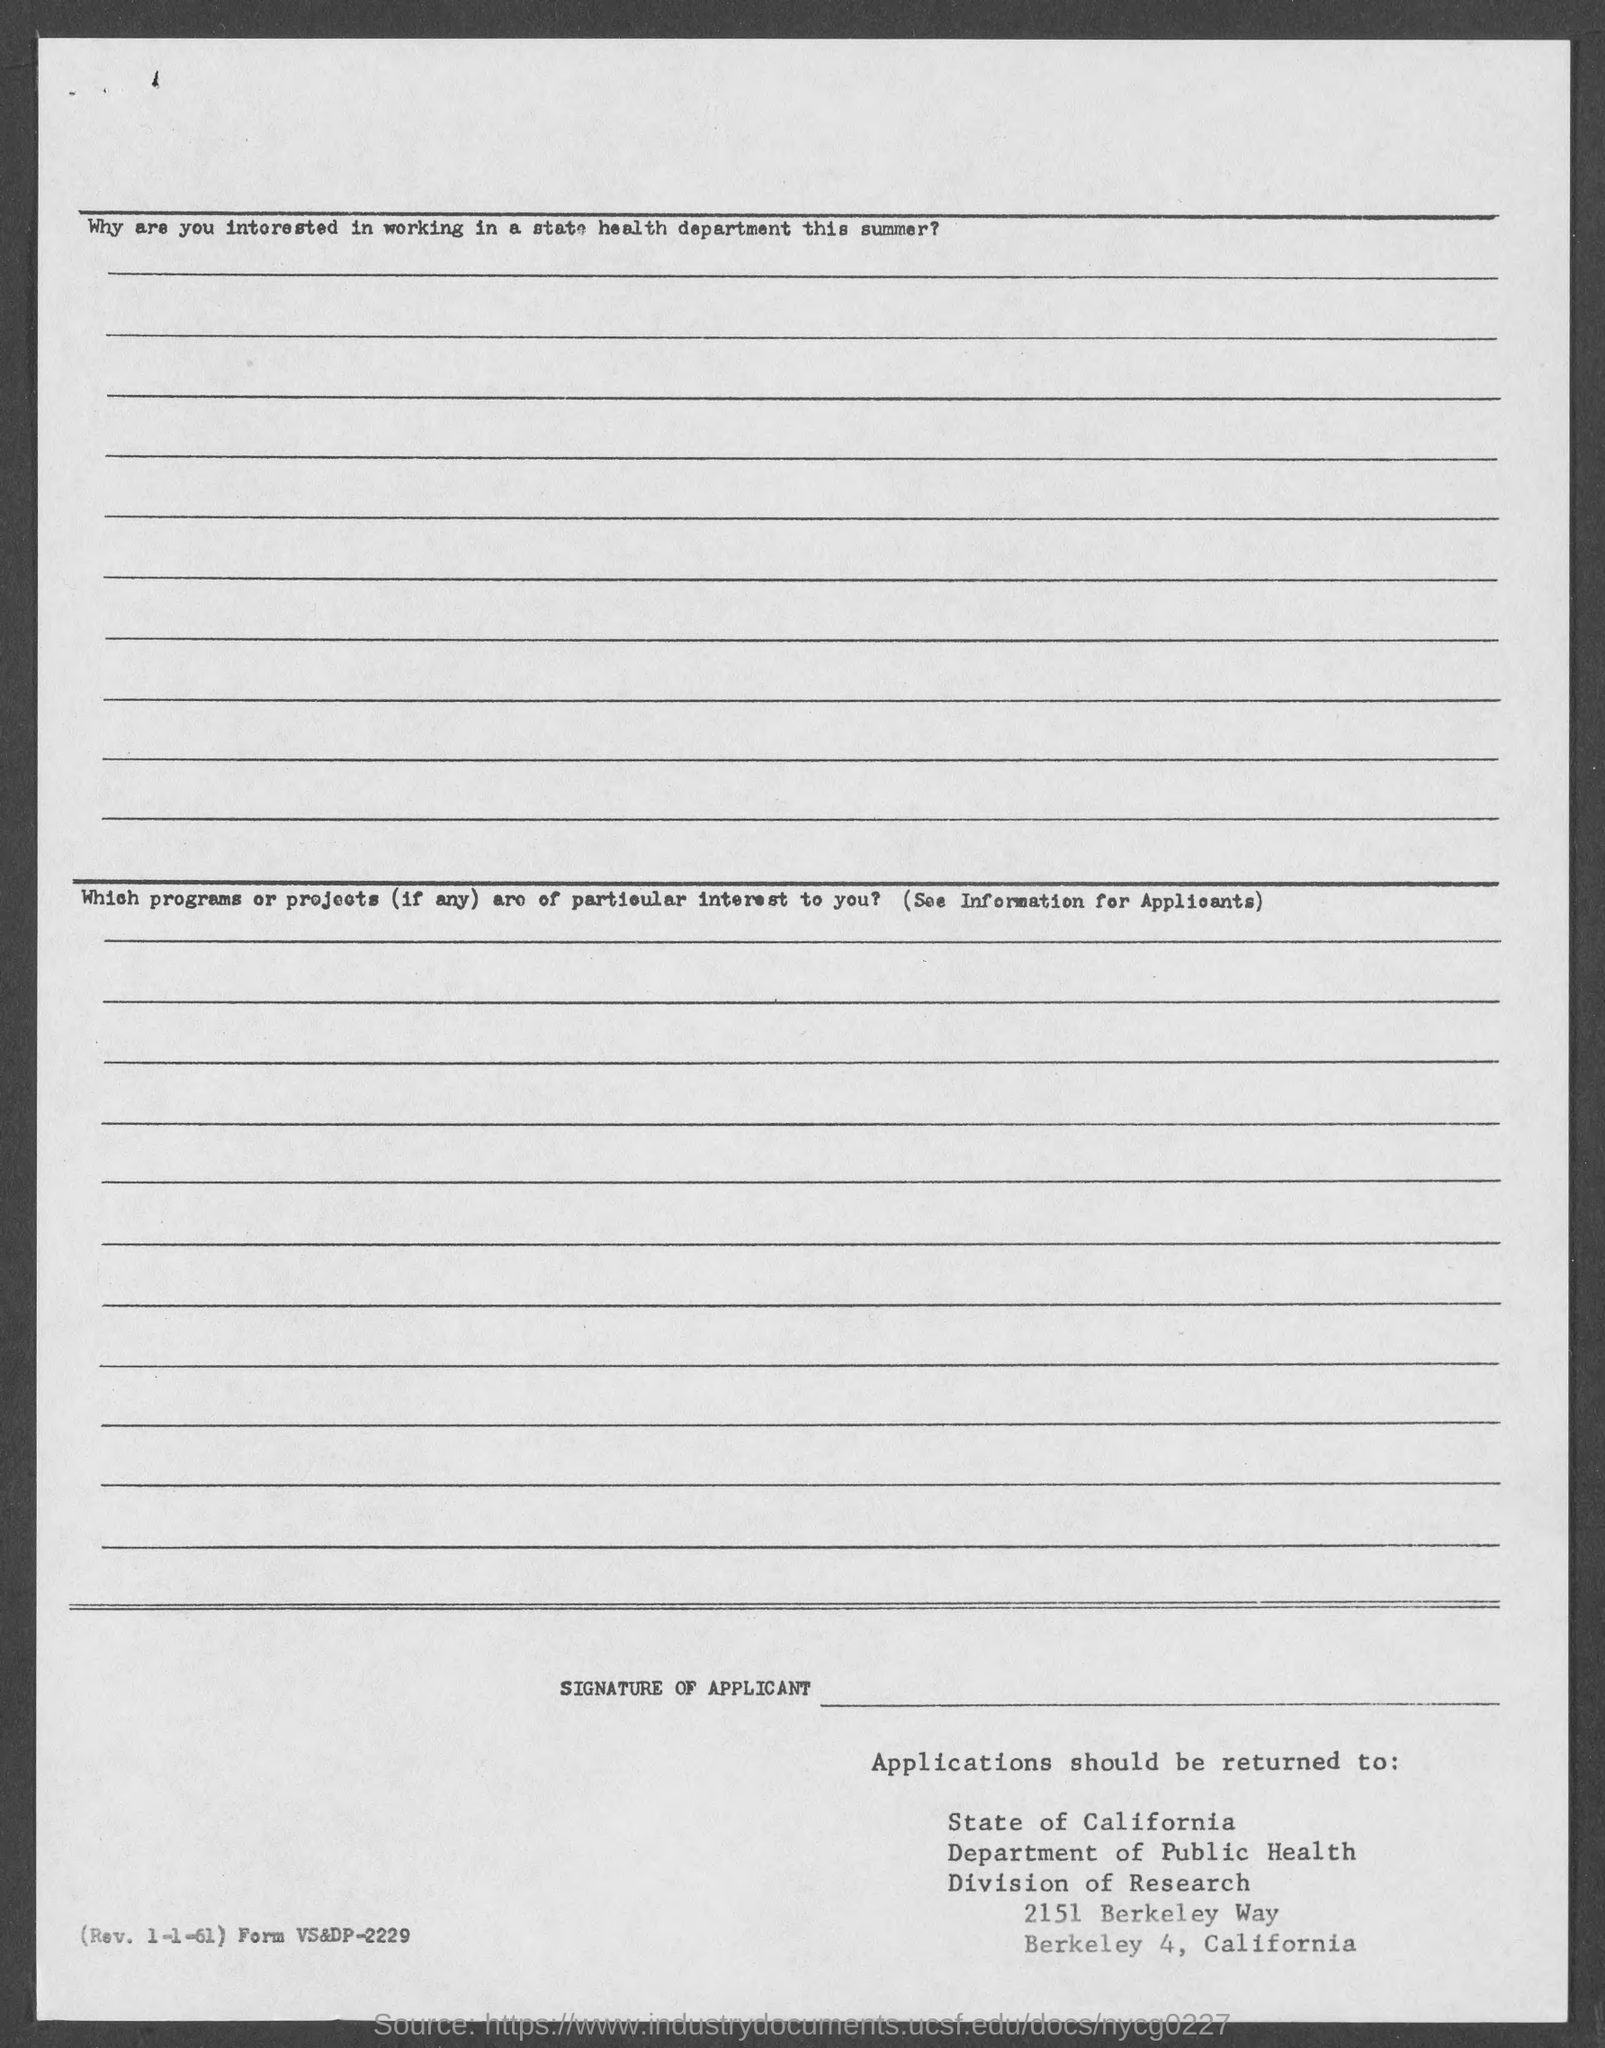List a handful of essential elements in this visual. The Department of Public Health is located within the Division of Research. 